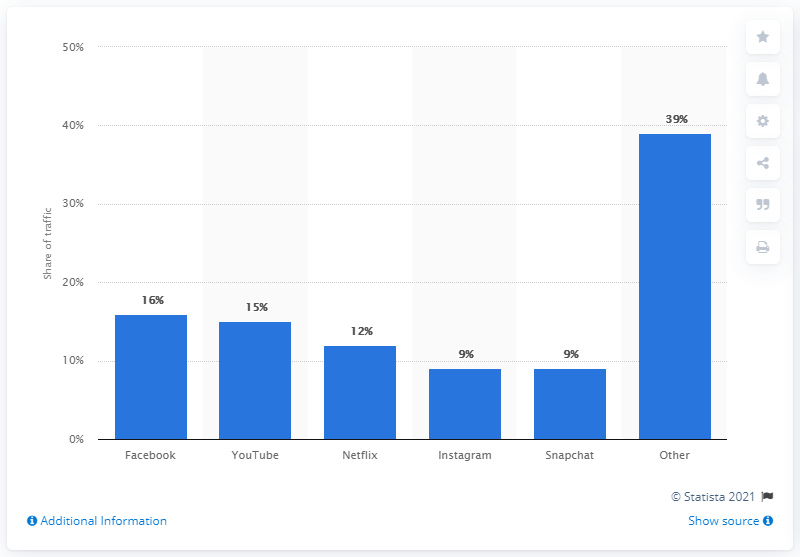Indicate a few pertinent items in this graphic. According to data, Facebook accounted for 16 percent of all mobile app traffic in 2021. 